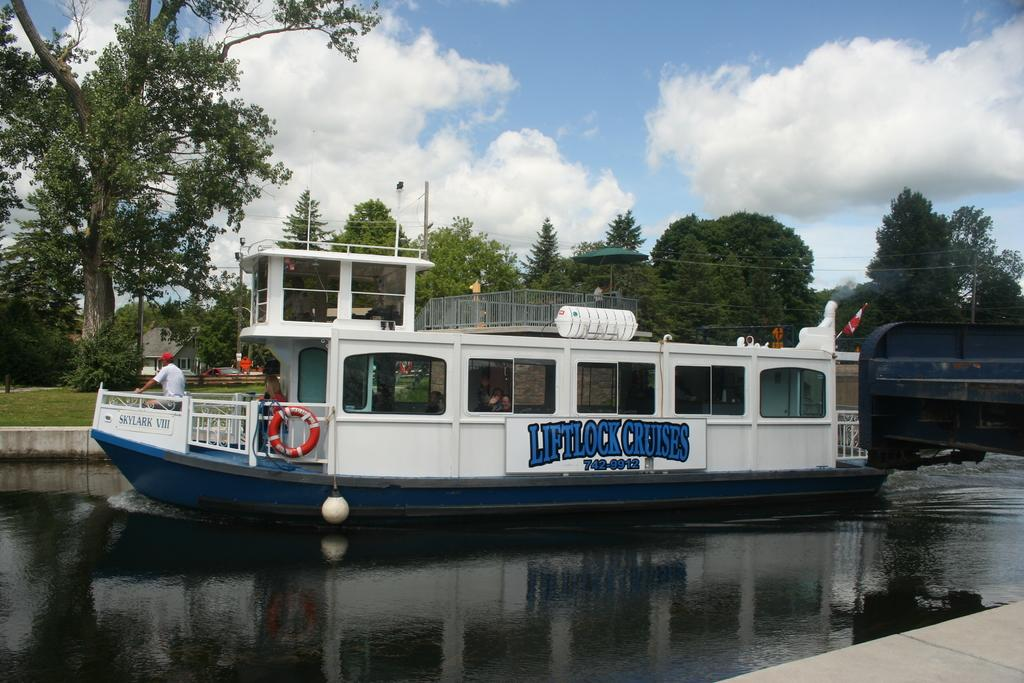What is the main subject in the middle of the image? There is a boat in the middle of the image. Where is the boat located? The boat is on the water. Are there any people in the boat? Yes, there are people in the boat. What can be seen in the background of the image? There are trees, poles, houses, and clouds in the background of the image. What type of ant can be seen crawling on the net in the image? There is no ant or net present in the image; it features a boat on the water with people in it and various background elements. 